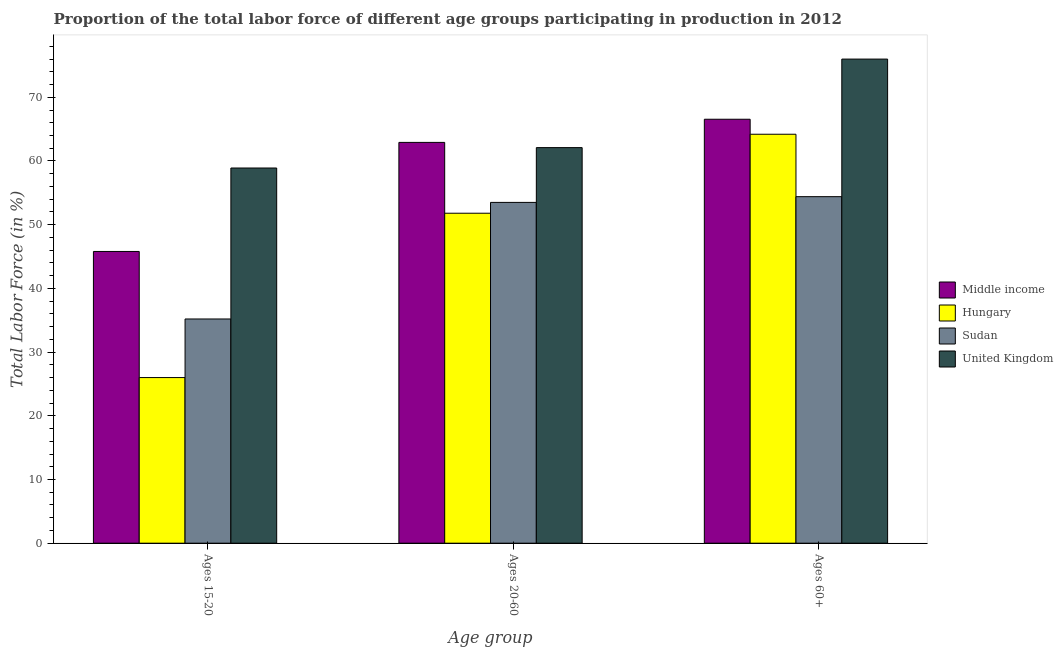How many different coloured bars are there?
Provide a succinct answer. 4. How many groups of bars are there?
Make the answer very short. 3. Are the number of bars per tick equal to the number of legend labels?
Your response must be concise. Yes. How many bars are there on the 3rd tick from the right?
Provide a short and direct response. 4. What is the label of the 3rd group of bars from the left?
Make the answer very short. Ages 60+. What is the percentage of labor force above age 60 in Hungary?
Offer a very short reply. 64.2. Across all countries, what is the maximum percentage of labor force within the age group 15-20?
Offer a very short reply. 58.9. Across all countries, what is the minimum percentage of labor force within the age group 20-60?
Ensure brevity in your answer.  51.8. In which country was the percentage of labor force within the age group 15-20 maximum?
Offer a very short reply. United Kingdom. In which country was the percentage of labor force above age 60 minimum?
Ensure brevity in your answer.  Sudan. What is the total percentage of labor force within the age group 15-20 in the graph?
Give a very brief answer. 165.9. What is the difference between the percentage of labor force within the age group 20-60 in Hungary and that in United Kingdom?
Your response must be concise. -10.3. What is the difference between the percentage of labor force above age 60 in Middle income and the percentage of labor force within the age group 20-60 in Hungary?
Make the answer very short. 14.75. What is the average percentage of labor force within the age group 15-20 per country?
Give a very brief answer. 41.47. What is the difference between the percentage of labor force above age 60 and percentage of labor force within the age group 15-20 in Sudan?
Keep it short and to the point. 19.2. In how many countries, is the percentage of labor force above age 60 greater than 24 %?
Give a very brief answer. 4. What is the ratio of the percentage of labor force within the age group 20-60 in Hungary to that in Middle income?
Provide a short and direct response. 0.82. Is the difference between the percentage of labor force within the age group 15-20 in Middle income and Hungary greater than the difference between the percentage of labor force above age 60 in Middle income and Hungary?
Offer a terse response. Yes. What is the difference between the highest and the second highest percentage of labor force above age 60?
Offer a terse response. 9.45. What is the difference between the highest and the lowest percentage of labor force within the age group 20-60?
Your response must be concise. 11.12. In how many countries, is the percentage of labor force within the age group 15-20 greater than the average percentage of labor force within the age group 15-20 taken over all countries?
Offer a terse response. 2. Are all the bars in the graph horizontal?
Give a very brief answer. No. What is the difference between two consecutive major ticks on the Y-axis?
Offer a terse response. 10. Does the graph contain grids?
Your answer should be compact. No. Where does the legend appear in the graph?
Keep it short and to the point. Center right. How are the legend labels stacked?
Your response must be concise. Vertical. What is the title of the graph?
Make the answer very short. Proportion of the total labor force of different age groups participating in production in 2012. What is the label or title of the X-axis?
Provide a short and direct response. Age group. What is the Total Labor Force (in %) in Middle income in Ages 15-20?
Offer a very short reply. 45.8. What is the Total Labor Force (in %) in Hungary in Ages 15-20?
Your answer should be compact. 26. What is the Total Labor Force (in %) in Sudan in Ages 15-20?
Provide a short and direct response. 35.2. What is the Total Labor Force (in %) in United Kingdom in Ages 15-20?
Ensure brevity in your answer.  58.9. What is the Total Labor Force (in %) in Middle income in Ages 20-60?
Ensure brevity in your answer.  62.92. What is the Total Labor Force (in %) of Hungary in Ages 20-60?
Provide a succinct answer. 51.8. What is the Total Labor Force (in %) of Sudan in Ages 20-60?
Your response must be concise. 53.5. What is the Total Labor Force (in %) in United Kingdom in Ages 20-60?
Your response must be concise. 62.1. What is the Total Labor Force (in %) of Middle income in Ages 60+?
Provide a succinct answer. 66.55. What is the Total Labor Force (in %) in Hungary in Ages 60+?
Provide a succinct answer. 64.2. What is the Total Labor Force (in %) in Sudan in Ages 60+?
Make the answer very short. 54.4. What is the Total Labor Force (in %) in United Kingdom in Ages 60+?
Make the answer very short. 76. Across all Age group, what is the maximum Total Labor Force (in %) of Middle income?
Your response must be concise. 66.55. Across all Age group, what is the maximum Total Labor Force (in %) in Hungary?
Make the answer very short. 64.2. Across all Age group, what is the maximum Total Labor Force (in %) of Sudan?
Provide a short and direct response. 54.4. Across all Age group, what is the maximum Total Labor Force (in %) in United Kingdom?
Provide a succinct answer. 76. Across all Age group, what is the minimum Total Labor Force (in %) of Middle income?
Make the answer very short. 45.8. Across all Age group, what is the minimum Total Labor Force (in %) in Sudan?
Your answer should be very brief. 35.2. Across all Age group, what is the minimum Total Labor Force (in %) in United Kingdom?
Keep it short and to the point. 58.9. What is the total Total Labor Force (in %) in Middle income in the graph?
Give a very brief answer. 175.27. What is the total Total Labor Force (in %) in Hungary in the graph?
Keep it short and to the point. 142. What is the total Total Labor Force (in %) of Sudan in the graph?
Offer a terse response. 143.1. What is the total Total Labor Force (in %) in United Kingdom in the graph?
Your response must be concise. 197. What is the difference between the Total Labor Force (in %) of Middle income in Ages 15-20 and that in Ages 20-60?
Offer a very short reply. -17.12. What is the difference between the Total Labor Force (in %) of Hungary in Ages 15-20 and that in Ages 20-60?
Give a very brief answer. -25.8. What is the difference between the Total Labor Force (in %) in Sudan in Ages 15-20 and that in Ages 20-60?
Make the answer very short. -18.3. What is the difference between the Total Labor Force (in %) of United Kingdom in Ages 15-20 and that in Ages 20-60?
Offer a very short reply. -3.2. What is the difference between the Total Labor Force (in %) in Middle income in Ages 15-20 and that in Ages 60+?
Make the answer very short. -20.76. What is the difference between the Total Labor Force (in %) in Hungary in Ages 15-20 and that in Ages 60+?
Provide a short and direct response. -38.2. What is the difference between the Total Labor Force (in %) in Sudan in Ages 15-20 and that in Ages 60+?
Offer a terse response. -19.2. What is the difference between the Total Labor Force (in %) in United Kingdom in Ages 15-20 and that in Ages 60+?
Your answer should be compact. -17.1. What is the difference between the Total Labor Force (in %) of Middle income in Ages 20-60 and that in Ages 60+?
Your answer should be very brief. -3.63. What is the difference between the Total Labor Force (in %) of Sudan in Ages 20-60 and that in Ages 60+?
Offer a terse response. -0.9. What is the difference between the Total Labor Force (in %) of Middle income in Ages 15-20 and the Total Labor Force (in %) of Hungary in Ages 20-60?
Offer a terse response. -6. What is the difference between the Total Labor Force (in %) in Middle income in Ages 15-20 and the Total Labor Force (in %) in Sudan in Ages 20-60?
Your answer should be compact. -7.7. What is the difference between the Total Labor Force (in %) of Middle income in Ages 15-20 and the Total Labor Force (in %) of United Kingdom in Ages 20-60?
Offer a very short reply. -16.3. What is the difference between the Total Labor Force (in %) of Hungary in Ages 15-20 and the Total Labor Force (in %) of Sudan in Ages 20-60?
Provide a succinct answer. -27.5. What is the difference between the Total Labor Force (in %) in Hungary in Ages 15-20 and the Total Labor Force (in %) in United Kingdom in Ages 20-60?
Make the answer very short. -36.1. What is the difference between the Total Labor Force (in %) in Sudan in Ages 15-20 and the Total Labor Force (in %) in United Kingdom in Ages 20-60?
Offer a very short reply. -26.9. What is the difference between the Total Labor Force (in %) in Middle income in Ages 15-20 and the Total Labor Force (in %) in Hungary in Ages 60+?
Provide a succinct answer. -18.4. What is the difference between the Total Labor Force (in %) of Middle income in Ages 15-20 and the Total Labor Force (in %) of Sudan in Ages 60+?
Make the answer very short. -8.6. What is the difference between the Total Labor Force (in %) in Middle income in Ages 15-20 and the Total Labor Force (in %) in United Kingdom in Ages 60+?
Give a very brief answer. -30.2. What is the difference between the Total Labor Force (in %) in Hungary in Ages 15-20 and the Total Labor Force (in %) in Sudan in Ages 60+?
Offer a terse response. -28.4. What is the difference between the Total Labor Force (in %) of Sudan in Ages 15-20 and the Total Labor Force (in %) of United Kingdom in Ages 60+?
Keep it short and to the point. -40.8. What is the difference between the Total Labor Force (in %) in Middle income in Ages 20-60 and the Total Labor Force (in %) in Hungary in Ages 60+?
Ensure brevity in your answer.  -1.28. What is the difference between the Total Labor Force (in %) of Middle income in Ages 20-60 and the Total Labor Force (in %) of Sudan in Ages 60+?
Ensure brevity in your answer.  8.52. What is the difference between the Total Labor Force (in %) in Middle income in Ages 20-60 and the Total Labor Force (in %) in United Kingdom in Ages 60+?
Your answer should be compact. -13.08. What is the difference between the Total Labor Force (in %) of Hungary in Ages 20-60 and the Total Labor Force (in %) of Sudan in Ages 60+?
Give a very brief answer. -2.6. What is the difference between the Total Labor Force (in %) in Hungary in Ages 20-60 and the Total Labor Force (in %) in United Kingdom in Ages 60+?
Your answer should be compact. -24.2. What is the difference between the Total Labor Force (in %) of Sudan in Ages 20-60 and the Total Labor Force (in %) of United Kingdom in Ages 60+?
Your answer should be very brief. -22.5. What is the average Total Labor Force (in %) in Middle income per Age group?
Your response must be concise. 58.42. What is the average Total Labor Force (in %) of Hungary per Age group?
Offer a very short reply. 47.33. What is the average Total Labor Force (in %) in Sudan per Age group?
Offer a very short reply. 47.7. What is the average Total Labor Force (in %) of United Kingdom per Age group?
Keep it short and to the point. 65.67. What is the difference between the Total Labor Force (in %) of Middle income and Total Labor Force (in %) of Hungary in Ages 15-20?
Your response must be concise. 19.8. What is the difference between the Total Labor Force (in %) of Middle income and Total Labor Force (in %) of Sudan in Ages 15-20?
Offer a very short reply. 10.6. What is the difference between the Total Labor Force (in %) of Middle income and Total Labor Force (in %) of United Kingdom in Ages 15-20?
Make the answer very short. -13.1. What is the difference between the Total Labor Force (in %) of Hungary and Total Labor Force (in %) of United Kingdom in Ages 15-20?
Offer a terse response. -32.9. What is the difference between the Total Labor Force (in %) of Sudan and Total Labor Force (in %) of United Kingdom in Ages 15-20?
Offer a very short reply. -23.7. What is the difference between the Total Labor Force (in %) in Middle income and Total Labor Force (in %) in Hungary in Ages 20-60?
Offer a very short reply. 11.12. What is the difference between the Total Labor Force (in %) in Middle income and Total Labor Force (in %) in Sudan in Ages 20-60?
Provide a short and direct response. 9.42. What is the difference between the Total Labor Force (in %) of Middle income and Total Labor Force (in %) of United Kingdom in Ages 20-60?
Your answer should be compact. 0.82. What is the difference between the Total Labor Force (in %) in Hungary and Total Labor Force (in %) in Sudan in Ages 20-60?
Ensure brevity in your answer.  -1.7. What is the difference between the Total Labor Force (in %) of Sudan and Total Labor Force (in %) of United Kingdom in Ages 20-60?
Offer a terse response. -8.6. What is the difference between the Total Labor Force (in %) in Middle income and Total Labor Force (in %) in Hungary in Ages 60+?
Your response must be concise. 2.35. What is the difference between the Total Labor Force (in %) in Middle income and Total Labor Force (in %) in Sudan in Ages 60+?
Your answer should be very brief. 12.15. What is the difference between the Total Labor Force (in %) in Middle income and Total Labor Force (in %) in United Kingdom in Ages 60+?
Provide a succinct answer. -9.45. What is the difference between the Total Labor Force (in %) in Sudan and Total Labor Force (in %) in United Kingdom in Ages 60+?
Make the answer very short. -21.6. What is the ratio of the Total Labor Force (in %) in Middle income in Ages 15-20 to that in Ages 20-60?
Provide a succinct answer. 0.73. What is the ratio of the Total Labor Force (in %) of Hungary in Ages 15-20 to that in Ages 20-60?
Your answer should be compact. 0.5. What is the ratio of the Total Labor Force (in %) in Sudan in Ages 15-20 to that in Ages 20-60?
Ensure brevity in your answer.  0.66. What is the ratio of the Total Labor Force (in %) in United Kingdom in Ages 15-20 to that in Ages 20-60?
Give a very brief answer. 0.95. What is the ratio of the Total Labor Force (in %) of Middle income in Ages 15-20 to that in Ages 60+?
Offer a terse response. 0.69. What is the ratio of the Total Labor Force (in %) in Hungary in Ages 15-20 to that in Ages 60+?
Your response must be concise. 0.41. What is the ratio of the Total Labor Force (in %) of Sudan in Ages 15-20 to that in Ages 60+?
Keep it short and to the point. 0.65. What is the ratio of the Total Labor Force (in %) in United Kingdom in Ages 15-20 to that in Ages 60+?
Offer a very short reply. 0.78. What is the ratio of the Total Labor Force (in %) in Middle income in Ages 20-60 to that in Ages 60+?
Ensure brevity in your answer.  0.95. What is the ratio of the Total Labor Force (in %) of Hungary in Ages 20-60 to that in Ages 60+?
Your answer should be very brief. 0.81. What is the ratio of the Total Labor Force (in %) in Sudan in Ages 20-60 to that in Ages 60+?
Offer a terse response. 0.98. What is the ratio of the Total Labor Force (in %) of United Kingdom in Ages 20-60 to that in Ages 60+?
Ensure brevity in your answer.  0.82. What is the difference between the highest and the second highest Total Labor Force (in %) of Middle income?
Provide a short and direct response. 3.63. What is the difference between the highest and the second highest Total Labor Force (in %) of Hungary?
Provide a short and direct response. 12.4. What is the difference between the highest and the second highest Total Labor Force (in %) in Sudan?
Your answer should be compact. 0.9. What is the difference between the highest and the lowest Total Labor Force (in %) of Middle income?
Provide a short and direct response. 20.76. What is the difference between the highest and the lowest Total Labor Force (in %) in Hungary?
Your response must be concise. 38.2. 